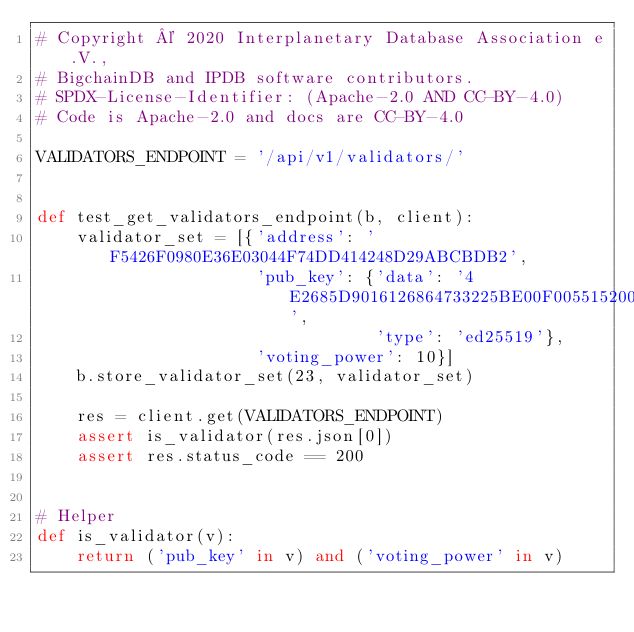<code> <loc_0><loc_0><loc_500><loc_500><_Python_># Copyright © 2020 Interplanetary Database Association e.V.,
# BigchainDB and IPDB software contributors.
# SPDX-License-Identifier: (Apache-2.0 AND CC-BY-4.0)
# Code is Apache-2.0 and docs are CC-BY-4.0

VALIDATORS_ENDPOINT = '/api/v1/validators/'


def test_get_validators_endpoint(b, client):
    validator_set = [{'address': 'F5426F0980E36E03044F74DD414248D29ABCBDB2',
                      'pub_key': {'data': '4E2685D9016126864733225BE00F005515200727FBAB1312FC78C8B76831255A',
                                  'type': 'ed25519'},
                      'voting_power': 10}]
    b.store_validator_set(23, validator_set)

    res = client.get(VALIDATORS_ENDPOINT)
    assert is_validator(res.json[0])
    assert res.status_code == 200


# Helper
def is_validator(v):
    return ('pub_key' in v) and ('voting_power' in v)
</code> 